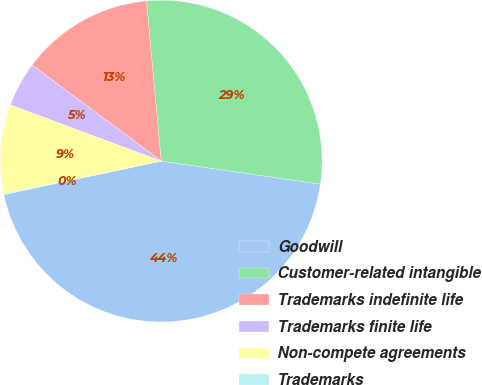<chart> <loc_0><loc_0><loc_500><loc_500><pie_chart><fcel>Goodwill<fcel>Customer-related intangible<fcel>Trademarks indefinite life<fcel>Trademarks finite life<fcel>Non-compete agreements<fcel>Trademarks<nl><fcel>44.37%<fcel>28.75%<fcel>13.36%<fcel>4.51%<fcel>8.94%<fcel>0.08%<nl></chart> 